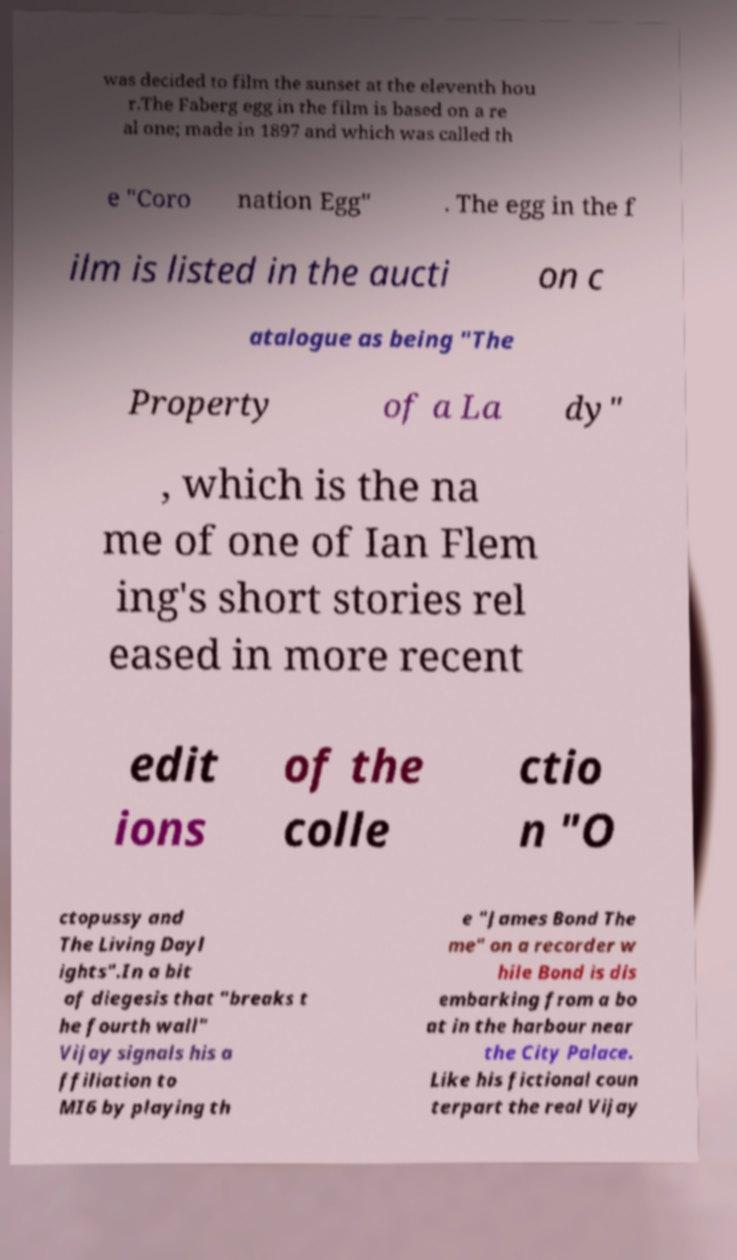There's text embedded in this image that I need extracted. Can you transcribe it verbatim? was decided to film the sunset at the eleventh hou r.The Faberg egg in the film is based on a re al one; made in 1897 and which was called th e "Coro nation Egg" . The egg in the f ilm is listed in the aucti on c atalogue as being "The Property of a La dy" , which is the na me of one of Ian Flem ing's short stories rel eased in more recent edit ions of the colle ctio n "O ctopussy and The Living Dayl ights".In a bit of diegesis that "breaks t he fourth wall" Vijay signals his a ffiliation to MI6 by playing th e "James Bond The me" on a recorder w hile Bond is dis embarking from a bo at in the harbour near the City Palace. Like his fictional coun terpart the real Vijay 